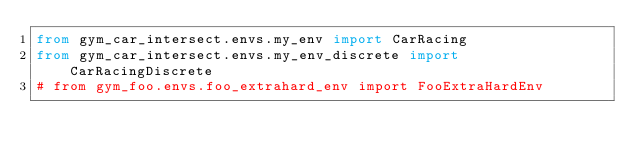<code> <loc_0><loc_0><loc_500><loc_500><_Python_>from gym_car_intersect.envs.my_env import CarRacing
from gym_car_intersect.envs.my_env_discrete import CarRacingDiscrete
# from gym_foo.envs.foo_extrahard_env import FooExtraHardEnv
</code> 